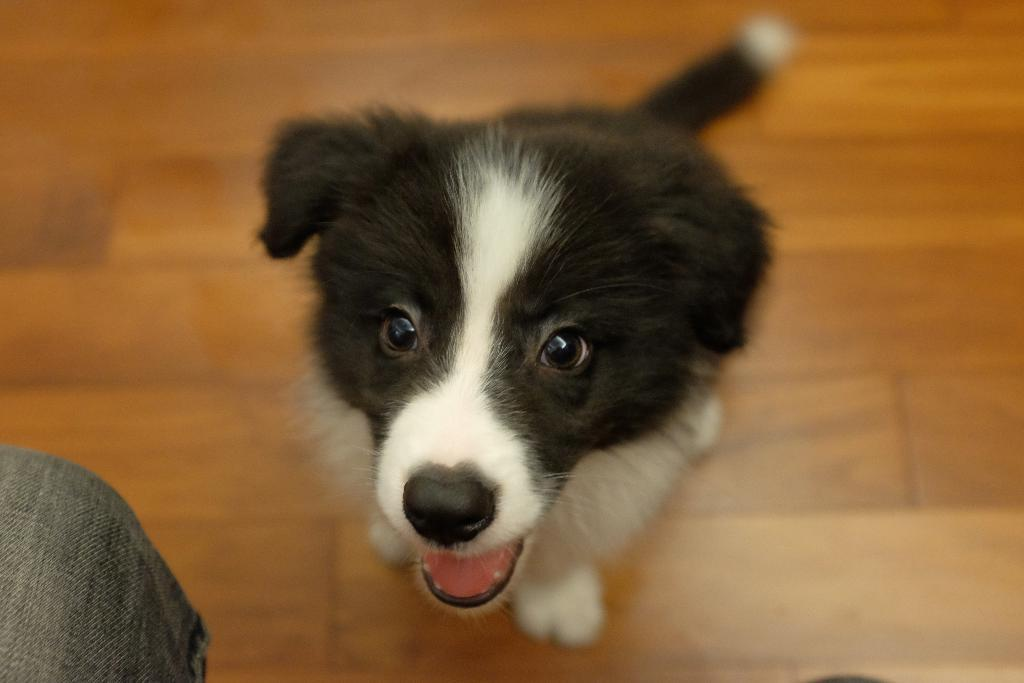What type of animal is in the image? There is a dog in the image. Can you describe the dog's coloring? The dog has white and black coloring. What is the dog standing on in the image? The dog is on a brown surface. Is there any part of a person visible in the image? Yes, there is a person's leg visible to the left of the dog. What type of metal object is the dog playing with on the sidewalk? There is no metal object or sidewalk present in the image; the dog is standing on a brown surface. 